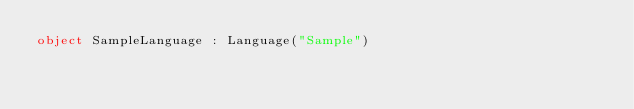Convert code to text. <code><loc_0><loc_0><loc_500><loc_500><_Kotlin_>object SampleLanguage : Language("Sample")</code> 